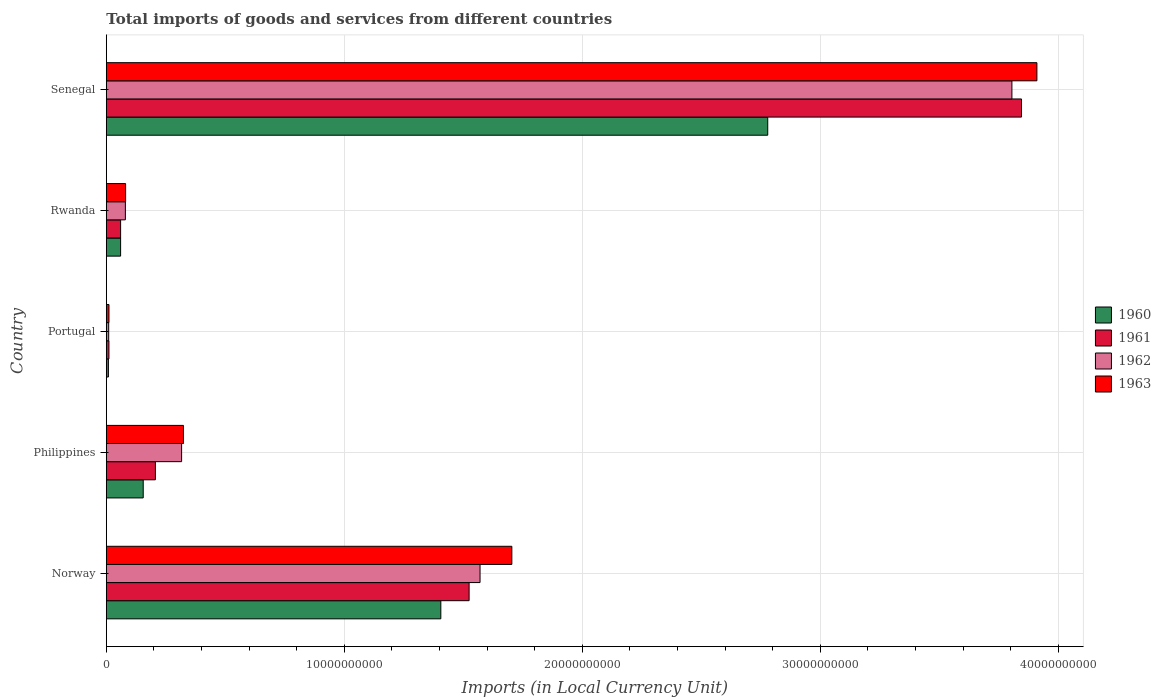How many different coloured bars are there?
Provide a short and direct response. 4. How many groups of bars are there?
Offer a terse response. 5. Are the number of bars per tick equal to the number of legend labels?
Make the answer very short. Yes. Are the number of bars on each tick of the Y-axis equal?
Your answer should be very brief. Yes. What is the Amount of goods and services imports in 1963 in Senegal?
Give a very brief answer. 3.91e+1. Across all countries, what is the maximum Amount of goods and services imports in 1961?
Make the answer very short. 3.85e+1. Across all countries, what is the minimum Amount of goods and services imports in 1963?
Ensure brevity in your answer.  1.11e+08. In which country was the Amount of goods and services imports in 1961 maximum?
Offer a terse response. Senegal. In which country was the Amount of goods and services imports in 1962 minimum?
Your answer should be compact. Portugal. What is the total Amount of goods and services imports in 1963 in the graph?
Your answer should be very brief. 6.03e+1. What is the difference between the Amount of goods and services imports in 1960 in Norway and that in Rwanda?
Your answer should be very brief. 1.35e+1. What is the difference between the Amount of goods and services imports in 1963 in Portugal and the Amount of goods and services imports in 1961 in Norway?
Provide a short and direct response. -1.51e+1. What is the average Amount of goods and services imports in 1961 per country?
Offer a terse response. 1.13e+1. What is the difference between the Amount of goods and services imports in 1961 and Amount of goods and services imports in 1962 in Rwanda?
Your response must be concise. -2.00e+08. In how many countries, is the Amount of goods and services imports in 1961 greater than 28000000000 LCU?
Provide a succinct answer. 1. What is the ratio of the Amount of goods and services imports in 1960 in Norway to that in Senegal?
Provide a succinct answer. 0.51. Is the Amount of goods and services imports in 1961 in Philippines less than that in Senegal?
Provide a short and direct response. Yes. Is the difference between the Amount of goods and services imports in 1961 in Philippines and Portugal greater than the difference between the Amount of goods and services imports in 1962 in Philippines and Portugal?
Ensure brevity in your answer.  No. What is the difference between the highest and the second highest Amount of goods and services imports in 1963?
Your answer should be very brief. 2.21e+1. What is the difference between the highest and the lowest Amount of goods and services imports in 1963?
Your answer should be compact. 3.90e+1. In how many countries, is the Amount of goods and services imports in 1962 greater than the average Amount of goods and services imports in 1962 taken over all countries?
Keep it short and to the point. 2. Is the sum of the Amount of goods and services imports in 1962 in Norway and Philippines greater than the maximum Amount of goods and services imports in 1963 across all countries?
Offer a terse response. No. Is it the case that in every country, the sum of the Amount of goods and services imports in 1963 and Amount of goods and services imports in 1961 is greater than the sum of Amount of goods and services imports in 1962 and Amount of goods and services imports in 1960?
Your response must be concise. No. What does the 3rd bar from the bottom in Norway represents?
Your answer should be very brief. 1962. How many bars are there?
Provide a short and direct response. 20. Are all the bars in the graph horizontal?
Make the answer very short. Yes. Does the graph contain any zero values?
Your answer should be very brief. No. Does the graph contain grids?
Ensure brevity in your answer.  Yes. What is the title of the graph?
Give a very brief answer. Total imports of goods and services from different countries. Does "2002" appear as one of the legend labels in the graph?
Give a very brief answer. No. What is the label or title of the X-axis?
Your response must be concise. Imports (in Local Currency Unit). What is the label or title of the Y-axis?
Give a very brief answer. Country. What is the Imports (in Local Currency Unit) in 1960 in Norway?
Give a very brief answer. 1.41e+1. What is the Imports (in Local Currency Unit) of 1961 in Norway?
Give a very brief answer. 1.52e+1. What is the Imports (in Local Currency Unit) of 1962 in Norway?
Ensure brevity in your answer.  1.57e+1. What is the Imports (in Local Currency Unit) in 1963 in Norway?
Your response must be concise. 1.70e+1. What is the Imports (in Local Currency Unit) of 1960 in Philippines?
Offer a terse response. 1.55e+09. What is the Imports (in Local Currency Unit) in 1961 in Philippines?
Provide a succinct answer. 2.06e+09. What is the Imports (in Local Currency Unit) in 1962 in Philippines?
Your response must be concise. 3.16e+09. What is the Imports (in Local Currency Unit) of 1963 in Philippines?
Ensure brevity in your answer.  3.24e+09. What is the Imports (in Local Currency Unit) of 1960 in Portugal?
Offer a very short reply. 8.70e+07. What is the Imports (in Local Currency Unit) in 1961 in Portugal?
Your answer should be very brief. 1.10e+08. What is the Imports (in Local Currency Unit) of 1962 in Portugal?
Make the answer very short. 9.89e+07. What is the Imports (in Local Currency Unit) of 1963 in Portugal?
Provide a succinct answer. 1.11e+08. What is the Imports (in Local Currency Unit) in 1960 in Rwanda?
Provide a short and direct response. 6.00e+08. What is the Imports (in Local Currency Unit) of 1961 in Rwanda?
Offer a terse response. 6.00e+08. What is the Imports (in Local Currency Unit) in 1962 in Rwanda?
Offer a terse response. 8.00e+08. What is the Imports (in Local Currency Unit) in 1963 in Rwanda?
Keep it short and to the point. 8.10e+08. What is the Imports (in Local Currency Unit) in 1960 in Senegal?
Offer a terse response. 2.78e+1. What is the Imports (in Local Currency Unit) in 1961 in Senegal?
Provide a short and direct response. 3.85e+1. What is the Imports (in Local Currency Unit) of 1962 in Senegal?
Your answer should be very brief. 3.81e+1. What is the Imports (in Local Currency Unit) of 1963 in Senegal?
Provide a succinct answer. 3.91e+1. Across all countries, what is the maximum Imports (in Local Currency Unit) in 1960?
Offer a very short reply. 2.78e+1. Across all countries, what is the maximum Imports (in Local Currency Unit) of 1961?
Give a very brief answer. 3.85e+1. Across all countries, what is the maximum Imports (in Local Currency Unit) in 1962?
Provide a short and direct response. 3.81e+1. Across all countries, what is the maximum Imports (in Local Currency Unit) in 1963?
Give a very brief answer. 3.91e+1. Across all countries, what is the minimum Imports (in Local Currency Unit) in 1960?
Your response must be concise. 8.70e+07. Across all countries, what is the minimum Imports (in Local Currency Unit) of 1961?
Make the answer very short. 1.10e+08. Across all countries, what is the minimum Imports (in Local Currency Unit) in 1962?
Your answer should be compact. 9.89e+07. Across all countries, what is the minimum Imports (in Local Currency Unit) in 1963?
Offer a very short reply. 1.11e+08. What is the total Imports (in Local Currency Unit) of 1960 in the graph?
Offer a terse response. 4.41e+1. What is the total Imports (in Local Currency Unit) in 1961 in the graph?
Your answer should be very brief. 5.65e+1. What is the total Imports (in Local Currency Unit) of 1962 in the graph?
Provide a succinct answer. 5.78e+1. What is the total Imports (in Local Currency Unit) of 1963 in the graph?
Provide a succinct answer. 6.03e+1. What is the difference between the Imports (in Local Currency Unit) in 1960 in Norway and that in Philippines?
Give a very brief answer. 1.25e+1. What is the difference between the Imports (in Local Currency Unit) in 1961 in Norway and that in Philippines?
Your answer should be very brief. 1.32e+1. What is the difference between the Imports (in Local Currency Unit) in 1962 in Norway and that in Philippines?
Ensure brevity in your answer.  1.25e+1. What is the difference between the Imports (in Local Currency Unit) in 1963 in Norway and that in Philippines?
Make the answer very short. 1.38e+1. What is the difference between the Imports (in Local Currency Unit) of 1960 in Norway and that in Portugal?
Your answer should be very brief. 1.40e+1. What is the difference between the Imports (in Local Currency Unit) in 1961 in Norway and that in Portugal?
Your answer should be compact. 1.51e+1. What is the difference between the Imports (in Local Currency Unit) of 1962 in Norway and that in Portugal?
Your answer should be very brief. 1.56e+1. What is the difference between the Imports (in Local Currency Unit) in 1963 in Norway and that in Portugal?
Provide a short and direct response. 1.69e+1. What is the difference between the Imports (in Local Currency Unit) in 1960 in Norway and that in Rwanda?
Your answer should be very brief. 1.35e+1. What is the difference between the Imports (in Local Currency Unit) of 1961 in Norway and that in Rwanda?
Your response must be concise. 1.46e+1. What is the difference between the Imports (in Local Currency Unit) of 1962 in Norway and that in Rwanda?
Offer a terse response. 1.49e+1. What is the difference between the Imports (in Local Currency Unit) in 1963 in Norway and that in Rwanda?
Your answer should be compact. 1.62e+1. What is the difference between the Imports (in Local Currency Unit) in 1960 in Norway and that in Senegal?
Keep it short and to the point. -1.37e+1. What is the difference between the Imports (in Local Currency Unit) in 1961 in Norway and that in Senegal?
Provide a short and direct response. -2.32e+1. What is the difference between the Imports (in Local Currency Unit) in 1962 in Norway and that in Senegal?
Provide a succinct answer. -2.23e+1. What is the difference between the Imports (in Local Currency Unit) in 1963 in Norway and that in Senegal?
Make the answer very short. -2.21e+1. What is the difference between the Imports (in Local Currency Unit) in 1960 in Philippines and that in Portugal?
Your response must be concise. 1.46e+09. What is the difference between the Imports (in Local Currency Unit) of 1961 in Philippines and that in Portugal?
Ensure brevity in your answer.  1.95e+09. What is the difference between the Imports (in Local Currency Unit) of 1962 in Philippines and that in Portugal?
Your answer should be very brief. 3.06e+09. What is the difference between the Imports (in Local Currency Unit) in 1963 in Philippines and that in Portugal?
Make the answer very short. 3.13e+09. What is the difference between the Imports (in Local Currency Unit) in 1960 in Philippines and that in Rwanda?
Provide a succinct answer. 9.50e+08. What is the difference between the Imports (in Local Currency Unit) of 1961 in Philippines and that in Rwanda?
Give a very brief answer. 1.46e+09. What is the difference between the Imports (in Local Currency Unit) of 1962 in Philippines and that in Rwanda?
Your answer should be very brief. 2.36e+09. What is the difference between the Imports (in Local Currency Unit) of 1963 in Philippines and that in Rwanda?
Give a very brief answer. 2.43e+09. What is the difference between the Imports (in Local Currency Unit) in 1960 in Philippines and that in Senegal?
Provide a succinct answer. -2.62e+1. What is the difference between the Imports (in Local Currency Unit) of 1961 in Philippines and that in Senegal?
Make the answer very short. -3.64e+1. What is the difference between the Imports (in Local Currency Unit) of 1962 in Philippines and that in Senegal?
Your answer should be compact. -3.49e+1. What is the difference between the Imports (in Local Currency Unit) in 1963 in Philippines and that in Senegal?
Ensure brevity in your answer.  -3.59e+1. What is the difference between the Imports (in Local Currency Unit) in 1960 in Portugal and that in Rwanda?
Offer a terse response. -5.13e+08. What is the difference between the Imports (in Local Currency Unit) of 1961 in Portugal and that in Rwanda?
Your answer should be compact. -4.90e+08. What is the difference between the Imports (in Local Currency Unit) in 1962 in Portugal and that in Rwanda?
Provide a short and direct response. -7.01e+08. What is the difference between the Imports (in Local Currency Unit) of 1963 in Portugal and that in Rwanda?
Provide a short and direct response. -6.99e+08. What is the difference between the Imports (in Local Currency Unit) in 1960 in Portugal and that in Senegal?
Offer a very short reply. -2.77e+1. What is the difference between the Imports (in Local Currency Unit) of 1961 in Portugal and that in Senegal?
Make the answer very short. -3.83e+1. What is the difference between the Imports (in Local Currency Unit) in 1962 in Portugal and that in Senegal?
Give a very brief answer. -3.80e+1. What is the difference between the Imports (in Local Currency Unit) in 1963 in Portugal and that in Senegal?
Offer a very short reply. -3.90e+1. What is the difference between the Imports (in Local Currency Unit) in 1960 in Rwanda and that in Senegal?
Provide a succinct answer. -2.72e+1. What is the difference between the Imports (in Local Currency Unit) in 1961 in Rwanda and that in Senegal?
Provide a short and direct response. -3.79e+1. What is the difference between the Imports (in Local Currency Unit) in 1962 in Rwanda and that in Senegal?
Make the answer very short. -3.73e+1. What is the difference between the Imports (in Local Currency Unit) of 1963 in Rwanda and that in Senegal?
Give a very brief answer. -3.83e+1. What is the difference between the Imports (in Local Currency Unit) of 1960 in Norway and the Imports (in Local Currency Unit) of 1961 in Philippines?
Provide a succinct answer. 1.20e+1. What is the difference between the Imports (in Local Currency Unit) in 1960 in Norway and the Imports (in Local Currency Unit) in 1962 in Philippines?
Your answer should be very brief. 1.09e+1. What is the difference between the Imports (in Local Currency Unit) of 1960 in Norway and the Imports (in Local Currency Unit) of 1963 in Philippines?
Provide a succinct answer. 1.08e+1. What is the difference between the Imports (in Local Currency Unit) in 1961 in Norway and the Imports (in Local Currency Unit) in 1962 in Philippines?
Your answer should be very brief. 1.21e+1. What is the difference between the Imports (in Local Currency Unit) in 1961 in Norway and the Imports (in Local Currency Unit) in 1963 in Philippines?
Give a very brief answer. 1.20e+1. What is the difference between the Imports (in Local Currency Unit) of 1962 in Norway and the Imports (in Local Currency Unit) of 1963 in Philippines?
Ensure brevity in your answer.  1.25e+1. What is the difference between the Imports (in Local Currency Unit) of 1960 in Norway and the Imports (in Local Currency Unit) of 1961 in Portugal?
Offer a terse response. 1.39e+1. What is the difference between the Imports (in Local Currency Unit) in 1960 in Norway and the Imports (in Local Currency Unit) in 1962 in Portugal?
Your answer should be very brief. 1.40e+1. What is the difference between the Imports (in Local Currency Unit) of 1960 in Norway and the Imports (in Local Currency Unit) of 1963 in Portugal?
Give a very brief answer. 1.39e+1. What is the difference between the Imports (in Local Currency Unit) of 1961 in Norway and the Imports (in Local Currency Unit) of 1962 in Portugal?
Provide a succinct answer. 1.51e+1. What is the difference between the Imports (in Local Currency Unit) of 1961 in Norway and the Imports (in Local Currency Unit) of 1963 in Portugal?
Provide a succinct answer. 1.51e+1. What is the difference between the Imports (in Local Currency Unit) in 1962 in Norway and the Imports (in Local Currency Unit) in 1963 in Portugal?
Offer a terse response. 1.56e+1. What is the difference between the Imports (in Local Currency Unit) in 1960 in Norway and the Imports (in Local Currency Unit) in 1961 in Rwanda?
Make the answer very short. 1.35e+1. What is the difference between the Imports (in Local Currency Unit) in 1960 in Norway and the Imports (in Local Currency Unit) in 1962 in Rwanda?
Give a very brief answer. 1.33e+1. What is the difference between the Imports (in Local Currency Unit) in 1960 in Norway and the Imports (in Local Currency Unit) in 1963 in Rwanda?
Your response must be concise. 1.32e+1. What is the difference between the Imports (in Local Currency Unit) of 1961 in Norway and the Imports (in Local Currency Unit) of 1962 in Rwanda?
Your response must be concise. 1.44e+1. What is the difference between the Imports (in Local Currency Unit) of 1961 in Norway and the Imports (in Local Currency Unit) of 1963 in Rwanda?
Ensure brevity in your answer.  1.44e+1. What is the difference between the Imports (in Local Currency Unit) in 1962 in Norway and the Imports (in Local Currency Unit) in 1963 in Rwanda?
Your response must be concise. 1.49e+1. What is the difference between the Imports (in Local Currency Unit) in 1960 in Norway and the Imports (in Local Currency Unit) in 1961 in Senegal?
Provide a succinct answer. -2.44e+1. What is the difference between the Imports (in Local Currency Unit) of 1960 in Norway and the Imports (in Local Currency Unit) of 1962 in Senegal?
Your response must be concise. -2.40e+1. What is the difference between the Imports (in Local Currency Unit) in 1960 in Norway and the Imports (in Local Currency Unit) in 1963 in Senegal?
Offer a very short reply. -2.50e+1. What is the difference between the Imports (in Local Currency Unit) in 1961 in Norway and the Imports (in Local Currency Unit) in 1962 in Senegal?
Ensure brevity in your answer.  -2.28e+1. What is the difference between the Imports (in Local Currency Unit) of 1961 in Norway and the Imports (in Local Currency Unit) of 1963 in Senegal?
Give a very brief answer. -2.39e+1. What is the difference between the Imports (in Local Currency Unit) in 1962 in Norway and the Imports (in Local Currency Unit) in 1963 in Senegal?
Give a very brief answer. -2.34e+1. What is the difference between the Imports (in Local Currency Unit) of 1960 in Philippines and the Imports (in Local Currency Unit) of 1961 in Portugal?
Offer a very short reply. 1.44e+09. What is the difference between the Imports (in Local Currency Unit) of 1960 in Philippines and the Imports (in Local Currency Unit) of 1962 in Portugal?
Offer a very short reply. 1.45e+09. What is the difference between the Imports (in Local Currency Unit) of 1960 in Philippines and the Imports (in Local Currency Unit) of 1963 in Portugal?
Provide a short and direct response. 1.44e+09. What is the difference between the Imports (in Local Currency Unit) in 1961 in Philippines and the Imports (in Local Currency Unit) in 1962 in Portugal?
Your answer should be compact. 1.96e+09. What is the difference between the Imports (in Local Currency Unit) of 1961 in Philippines and the Imports (in Local Currency Unit) of 1963 in Portugal?
Your answer should be compact. 1.95e+09. What is the difference between the Imports (in Local Currency Unit) in 1962 in Philippines and the Imports (in Local Currency Unit) in 1963 in Portugal?
Your response must be concise. 3.05e+09. What is the difference between the Imports (in Local Currency Unit) of 1960 in Philippines and the Imports (in Local Currency Unit) of 1961 in Rwanda?
Offer a terse response. 9.50e+08. What is the difference between the Imports (in Local Currency Unit) in 1960 in Philippines and the Imports (in Local Currency Unit) in 1962 in Rwanda?
Your response must be concise. 7.50e+08. What is the difference between the Imports (in Local Currency Unit) in 1960 in Philippines and the Imports (in Local Currency Unit) in 1963 in Rwanda?
Ensure brevity in your answer.  7.40e+08. What is the difference between the Imports (in Local Currency Unit) in 1961 in Philippines and the Imports (in Local Currency Unit) in 1962 in Rwanda?
Give a very brief answer. 1.26e+09. What is the difference between the Imports (in Local Currency Unit) of 1961 in Philippines and the Imports (in Local Currency Unit) of 1963 in Rwanda?
Provide a short and direct response. 1.25e+09. What is the difference between the Imports (in Local Currency Unit) of 1962 in Philippines and the Imports (in Local Currency Unit) of 1963 in Rwanda?
Ensure brevity in your answer.  2.35e+09. What is the difference between the Imports (in Local Currency Unit) in 1960 in Philippines and the Imports (in Local Currency Unit) in 1961 in Senegal?
Provide a succinct answer. -3.69e+1. What is the difference between the Imports (in Local Currency Unit) in 1960 in Philippines and the Imports (in Local Currency Unit) in 1962 in Senegal?
Keep it short and to the point. -3.65e+1. What is the difference between the Imports (in Local Currency Unit) in 1960 in Philippines and the Imports (in Local Currency Unit) in 1963 in Senegal?
Provide a succinct answer. -3.76e+1. What is the difference between the Imports (in Local Currency Unit) in 1961 in Philippines and the Imports (in Local Currency Unit) in 1962 in Senegal?
Keep it short and to the point. -3.60e+1. What is the difference between the Imports (in Local Currency Unit) in 1961 in Philippines and the Imports (in Local Currency Unit) in 1963 in Senegal?
Make the answer very short. -3.70e+1. What is the difference between the Imports (in Local Currency Unit) in 1962 in Philippines and the Imports (in Local Currency Unit) in 1963 in Senegal?
Keep it short and to the point. -3.59e+1. What is the difference between the Imports (in Local Currency Unit) in 1960 in Portugal and the Imports (in Local Currency Unit) in 1961 in Rwanda?
Your response must be concise. -5.13e+08. What is the difference between the Imports (in Local Currency Unit) of 1960 in Portugal and the Imports (in Local Currency Unit) of 1962 in Rwanda?
Offer a terse response. -7.13e+08. What is the difference between the Imports (in Local Currency Unit) in 1960 in Portugal and the Imports (in Local Currency Unit) in 1963 in Rwanda?
Provide a short and direct response. -7.23e+08. What is the difference between the Imports (in Local Currency Unit) of 1961 in Portugal and the Imports (in Local Currency Unit) of 1962 in Rwanda?
Your response must be concise. -6.90e+08. What is the difference between the Imports (in Local Currency Unit) of 1961 in Portugal and the Imports (in Local Currency Unit) of 1963 in Rwanda?
Offer a very short reply. -7.00e+08. What is the difference between the Imports (in Local Currency Unit) in 1962 in Portugal and the Imports (in Local Currency Unit) in 1963 in Rwanda?
Offer a terse response. -7.11e+08. What is the difference between the Imports (in Local Currency Unit) of 1960 in Portugal and the Imports (in Local Currency Unit) of 1961 in Senegal?
Your answer should be very brief. -3.84e+1. What is the difference between the Imports (in Local Currency Unit) of 1960 in Portugal and the Imports (in Local Currency Unit) of 1962 in Senegal?
Give a very brief answer. -3.80e+1. What is the difference between the Imports (in Local Currency Unit) in 1960 in Portugal and the Imports (in Local Currency Unit) in 1963 in Senegal?
Offer a very short reply. -3.90e+1. What is the difference between the Imports (in Local Currency Unit) in 1961 in Portugal and the Imports (in Local Currency Unit) in 1962 in Senegal?
Offer a very short reply. -3.79e+1. What is the difference between the Imports (in Local Currency Unit) of 1961 in Portugal and the Imports (in Local Currency Unit) of 1963 in Senegal?
Your answer should be compact. -3.90e+1. What is the difference between the Imports (in Local Currency Unit) in 1962 in Portugal and the Imports (in Local Currency Unit) in 1963 in Senegal?
Give a very brief answer. -3.90e+1. What is the difference between the Imports (in Local Currency Unit) of 1960 in Rwanda and the Imports (in Local Currency Unit) of 1961 in Senegal?
Ensure brevity in your answer.  -3.79e+1. What is the difference between the Imports (in Local Currency Unit) of 1960 in Rwanda and the Imports (in Local Currency Unit) of 1962 in Senegal?
Give a very brief answer. -3.75e+1. What is the difference between the Imports (in Local Currency Unit) of 1960 in Rwanda and the Imports (in Local Currency Unit) of 1963 in Senegal?
Ensure brevity in your answer.  -3.85e+1. What is the difference between the Imports (in Local Currency Unit) of 1961 in Rwanda and the Imports (in Local Currency Unit) of 1962 in Senegal?
Offer a terse response. -3.75e+1. What is the difference between the Imports (in Local Currency Unit) in 1961 in Rwanda and the Imports (in Local Currency Unit) in 1963 in Senegal?
Make the answer very short. -3.85e+1. What is the difference between the Imports (in Local Currency Unit) in 1962 in Rwanda and the Imports (in Local Currency Unit) in 1963 in Senegal?
Provide a short and direct response. -3.83e+1. What is the average Imports (in Local Currency Unit) in 1960 per country?
Give a very brief answer. 8.82e+09. What is the average Imports (in Local Currency Unit) in 1961 per country?
Keep it short and to the point. 1.13e+1. What is the average Imports (in Local Currency Unit) of 1962 per country?
Your response must be concise. 1.16e+1. What is the average Imports (in Local Currency Unit) in 1963 per country?
Give a very brief answer. 1.21e+1. What is the difference between the Imports (in Local Currency Unit) of 1960 and Imports (in Local Currency Unit) of 1961 in Norway?
Your answer should be compact. -1.19e+09. What is the difference between the Imports (in Local Currency Unit) of 1960 and Imports (in Local Currency Unit) of 1962 in Norway?
Keep it short and to the point. -1.65e+09. What is the difference between the Imports (in Local Currency Unit) in 1960 and Imports (in Local Currency Unit) in 1963 in Norway?
Your answer should be compact. -2.98e+09. What is the difference between the Imports (in Local Currency Unit) in 1961 and Imports (in Local Currency Unit) in 1962 in Norway?
Give a very brief answer. -4.60e+08. What is the difference between the Imports (in Local Currency Unit) in 1961 and Imports (in Local Currency Unit) in 1963 in Norway?
Keep it short and to the point. -1.80e+09. What is the difference between the Imports (in Local Currency Unit) in 1962 and Imports (in Local Currency Unit) in 1963 in Norway?
Offer a terse response. -1.34e+09. What is the difference between the Imports (in Local Currency Unit) of 1960 and Imports (in Local Currency Unit) of 1961 in Philippines?
Your answer should be very brief. -5.12e+08. What is the difference between the Imports (in Local Currency Unit) in 1960 and Imports (in Local Currency Unit) in 1962 in Philippines?
Ensure brevity in your answer.  -1.61e+09. What is the difference between the Imports (in Local Currency Unit) of 1960 and Imports (in Local Currency Unit) of 1963 in Philippines?
Provide a short and direct response. -1.69e+09. What is the difference between the Imports (in Local Currency Unit) in 1961 and Imports (in Local Currency Unit) in 1962 in Philippines?
Make the answer very short. -1.10e+09. What is the difference between the Imports (in Local Currency Unit) in 1961 and Imports (in Local Currency Unit) in 1963 in Philippines?
Offer a very short reply. -1.18e+09. What is the difference between the Imports (in Local Currency Unit) of 1962 and Imports (in Local Currency Unit) of 1963 in Philippines?
Keep it short and to the point. -7.75e+07. What is the difference between the Imports (in Local Currency Unit) of 1960 and Imports (in Local Currency Unit) of 1961 in Portugal?
Make the answer very short. -2.27e+07. What is the difference between the Imports (in Local Currency Unit) in 1960 and Imports (in Local Currency Unit) in 1962 in Portugal?
Give a very brief answer. -1.18e+07. What is the difference between the Imports (in Local Currency Unit) in 1960 and Imports (in Local Currency Unit) in 1963 in Portugal?
Ensure brevity in your answer.  -2.37e+07. What is the difference between the Imports (in Local Currency Unit) of 1961 and Imports (in Local Currency Unit) of 1962 in Portugal?
Ensure brevity in your answer.  1.08e+07. What is the difference between the Imports (in Local Currency Unit) in 1961 and Imports (in Local Currency Unit) in 1963 in Portugal?
Give a very brief answer. -1.03e+06. What is the difference between the Imports (in Local Currency Unit) of 1962 and Imports (in Local Currency Unit) of 1963 in Portugal?
Give a very brief answer. -1.18e+07. What is the difference between the Imports (in Local Currency Unit) of 1960 and Imports (in Local Currency Unit) of 1962 in Rwanda?
Your answer should be very brief. -2.00e+08. What is the difference between the Imports (in Local Currency Unit) in 1960 and Imports (in Local Currency Unit) in 1963 in Rwanda?
Provide a short and direct response. -2.10e+08. What is the difference between the Imports (in Local Currency Unit) in 1961 and Imports (in Local Currency Unit) in 1962 in Rwanda?
Your answer should be very brief. -2.00e+08. What is the difference between the Imports (in Local Currency Unit) of 1961 and Imports (in Local Currency Unit) of 1963 in Rwanda?
Offer a terse response. -2.10e+08. What is the difference between the Imports (in Local Currency Unit) of 1962 and Imports (in Local Currency Unit) of 1963 in Rwanda?
Make the answer very short. -1.00e+07. What is the difference between the Imports (in Local Currency Unit) of 1960 and Imports (in Local Currency Unit) of 1961 in Senegal?
Your answer should be very brief. -1.07e+1. What is the difference between the Imports (in Local Currency Unit) of 1960 and Imports (in Local Currency Unit) of 1962 in Senegal?
Your response must be concise. -1.03e+1. What is the difference between the Imports (in Local Currency Unit) of 1960 and Imports (in Local Currency Unit) of 1963 in Senegal?
Your answer should be compact. -1.13e+1. What is the difference between the Imports (in Local Currency Unit) in 1961 and Imports (in Local Currency Unit) in 1962 in Senegal?
Offer a terse response. 4.04e+08. What is the difference between the Imports (in Local Currency Unit) of 1961 and Imports (in Local Currency Unit) of 1963 in Senegal?
Your answer should be very brief. -6.46e+08. What is the difference between the Imports (in Local Currency Unit) in 1962 and Imports (in Local Currency Unit) in 1963 in Senegal?
Ensure brevity in your answer.  -1.05e+09. What is the ratio of the Imports (in Local Currency Unit) of 1960 in Norway to that in Philippines?
Keep it short and to the point. 9.07. What is the ratio of the Imports (in Local Currency Unit) in 1961 in Norway to that in Philippines?
Offer a very short reply. 7.4. What is the ratio of the Imports (in Local Currency Unit) of 1962 in Norway to that in Philippines?
Provide a succinct answer. 4.96. What is the ratio of the Imports (in Local Currency Unit) of 1963 in Norway to that in Philippines?
Offer a very short reply. 5.26. What is the ratio of the Imports (in Local Currency Unit) in 1960 in Norway to that in Portugal?
Offer a very short reply. 161.47. What is the ratio of the Imports (in Local Currency Unit) in 1961 in Norway to that in Portugal?
Keep it short and to the point. 138.95. What is the ratio of the Imports (in Local Currency Unit) in 1962 in Norway to that in Portugal?
Provide a succinct answer. 158.79. What is the ratio of the Imports (in Local Currency Unit) in 1963 in Norway to that in Portugal?
Your answer should be compact. 153.87. What is the ratio of the Imports (in Local Currency Unit) in 1960 in Norway to that in Rwanda?
Keep it short and to the point. 23.43. What is the ratio of the Imports (in Local Currency Unit) in 1961 in Norway to that in Rwanda?
Provide a short and direct response. 25.41. What is the ratio of the Imports (in Local Currency Unit) of 1962 in Norway to that in Rwanda?
Your response must be concise. 19.63. What is the ratio of the Imports (in Local Currency Unit) of 1963 in Norway to that in Rwanda?
Keep it short and to the point. 21.04. What is the ratio of the Imports (in Local Currency Unit) in 1960 in Norway to that in Senegal?
Offer a terse response. 0.51. What is the ratio of the Imports (in Local Currency Unit) in 1961 in Norway to that in Senegal?
Your response must be concise. 0.4. What is the ratio of the Imports (in Local Currency Unit) in 1962 in Norway to that in Senegal?
Ensure brevity in your answer.  0.41. What is the ratio of the Imports (in Local Currency Unit) of 1963 in Norway to that in Senegal?
Your response must be concise. 0.44. What is the ratio of the Imports (in Local Currency Unit) in 1960 in Philippines to that in Portugal?
Your answer should be compact. 17.8. What is the ratio of the Imports (in Local Currency Unit) in 1961 in Philippines to that in Portugal?
Your answer should be compact. 18.79. What is the ratio of the Imports (in Local Currency Unit) in 1962 in Philippines to that in Portugal?
Give a very brief answer. 31.98. What is the ratio of the Imports (in Local Currency Unit) of 1963 in Philippines to that in Portugal?
Give a very brief answer. 29.26. What is the ratio of the Imports (in Local Currency Unit) in 1960 in Philippines to that in Rwanda?
Offer a very short reply. 2.58. What is the ratio of the Imports (in Local Currency Unit) of 1961 in Philippines to that in Rwanda?
Your response must be concise. 3.44. What is the ratio of the Imports (in Local Currency Unit) of 1962 in Philippines to that in Rwanda?
Give a very brief answer. 3.95. What is the ratio of the Imports (in Local Currency Unit) of 1963 in Philippines to that in Rwanda?
Provide a short and direct response. 4. What is the ratio of the Imports (in Local Currency Unit) in 1960 in Philippines to that in Senegal?
Offer a terse response. 0.06. What is the ratio of the Imports (in Local Currency Unit) in 1961 in Philippines to that in Senegal?
Offer a terse response. 0.05. What is the ratio of the Imports (in Local Currency Unit) of 1962 in Philippines to that in Senegal?
Keep it short and to the point. 0.08. What is the ratio of the Imports (in Local Currency Unit) of 1963 in Philippines to that in Senegal?
Offer a terse response. 0.08. What is the ratio of the Imports (in Local Currency Unit) of 1960 in Portugal to that in Rwanda?
Keep it short and to the point. 0.15. What is the ratio of the Imports (in Local Currency Unit) in 1961 in Portugal to that in Rwanda?
Provide a short and direct response. 0.18. What is the ratio of the Imports (in Local Currency Unit) of 1962 in Portugal to that in Rwanda?
Give a very brief answer. 0.12. What is the ratio of the Imports (in Local Currency Unit) in 1963 in Portugal to that in Rwanda?
Provide a succinct answer. 0.14. What is the ratio of the Imports (in Local Currency Unit) of 1960 in Portugal to that in Senegal?
Make the answer very short. 0. What is the ratio of the Imports (in Local Currency Unit) of 1961 in Portugal to that in Senegal?
Offer a very short reply. 0. What is the ratio of the Imports (in Local Currency Unit) of 1962 in Portugal to that in Senegal?
Your answer should be compact. 0. What is the ratio of the Imports (in Local Currency Unit) of 1963 in Portugal to that in Senegal?
Provide a succinct answer. 0. What is the ratio of the Imports (in Local Currency Unit) in 1960 in Rwanda to that in Senegal?
Keep it short and to the point. 0.02. What is the ratio of the Imports (in Local Currency Unit) in 1961 in Rwanda to that in Senegal?
Provide a short and direct response. 0.02. What is the ratio of the Imports (in Local Currency Unit) of 1962 in Rwanda to that in Senegal?
Offer a terse response. 0.02. What is the ratio of the Imports (in Local Currency Unit) of 1963 in Rwanda to that in Senegal?
Your response must be concise. 0.02. What is the difference between the highest and the second highest Imports (in Local Currency Unit) of 1960?
Ensure brevity in your answer.  1.37e+1. What is the difference between the highest and the second highest Imports (in Local Currency Unit) of 1961?
Your response must be concise. 2.32e+1. What is the difference between the highest and the second highest Imports (in Local Currency Unit) of 1962?
Your answer should be very brief. 2.23e+1. What is the difference between the highest and the second highest Imports (in Local Currency Unit) of 1963?
Provide a succinct answer. 2.21e+1. What is the difference between the highest and the lowest Imports (in Local Currency Unit) in 1960?
Your answer should be compact. 2.77e+1. What is the difference between the highest and the lowest Imports (in Local Currency Unit) of 1961?
Offer a terse response. 3.83e+1. What is the difference between the highest and the lowest Imports (in Local Currency Unit) in 1962?
Provide a succinct answer. 3.80e+1. What is the difference between the highest and the lowest Imports (in Local Currency Unit) in 1963?
Keep it short and to the point. 3.90e+1. 